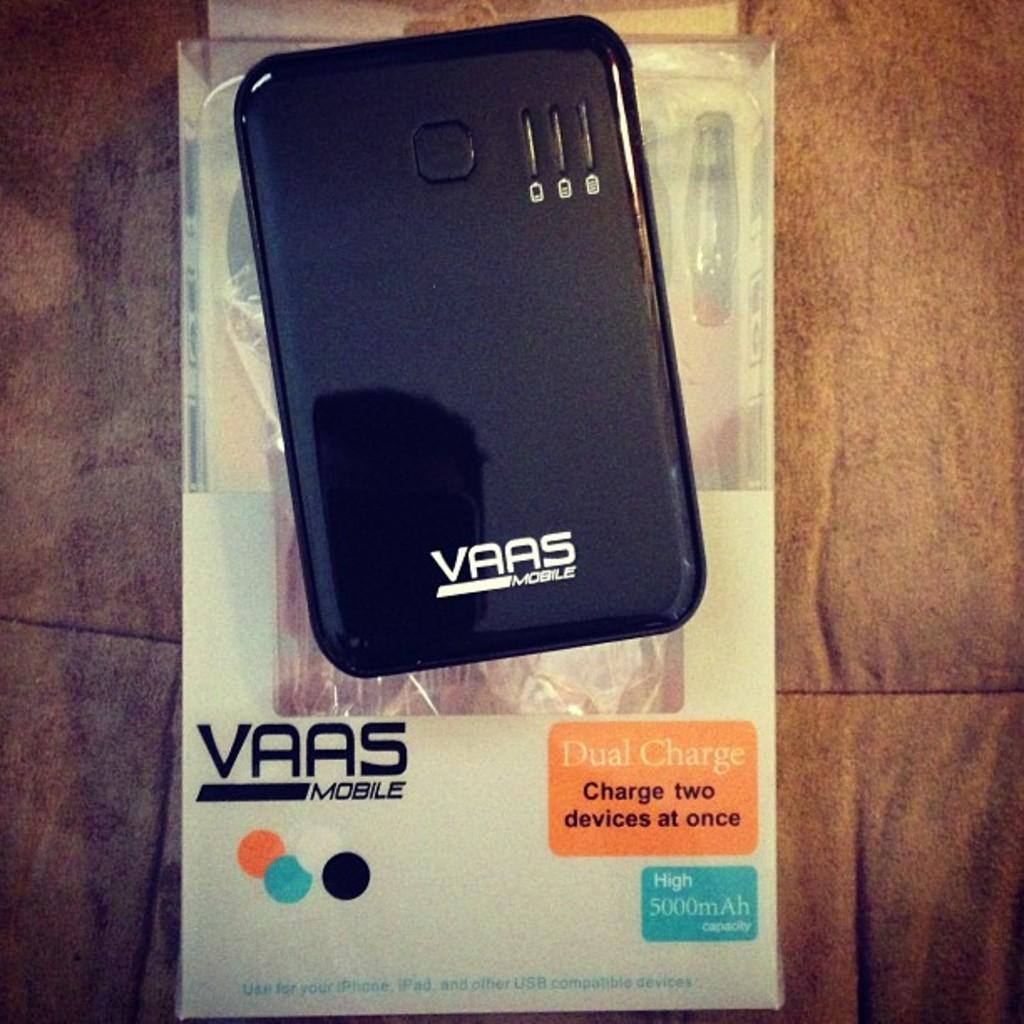Describe this image in one or two sentences. There is a black color mobile which has vaas mobile written on it and there is a box under it. 